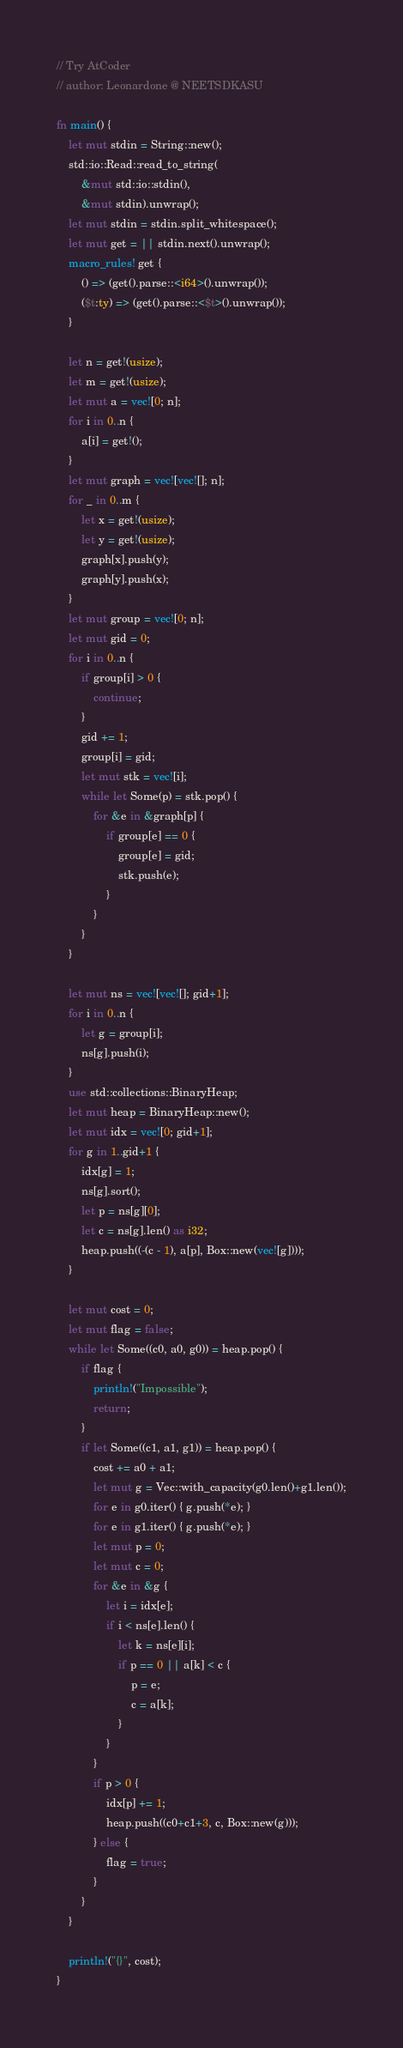<code> <loc_0><loc_0><loc_500><loc_500><_Rust_>// Try AtCoder
// author: Leonardone @ NEETSDKASU

fn main() {
    let mut stdin = String::new();
    std::io::Read::read_to_string(
    	&mut std::io::stdin(),
        &mut stdin).unwrap();
	let mut stdin = stdin.split_whitespace();
    let mut get = || stdin.next().unwrap();
    macro_rules! get {
    	() => (get().parse::<i64>().unwrap());
        ($t:ty) => (get().parse::<$t>().unwrap());
    }
    
    let n = get!(usize);
    let m = get!(usize);
    let mut a = vec![0; n];
    for i in 0..n {
    	a[i] = get!();
    }
    let mut graph = vec![vec![]; n];
    for _ in 0..m {
    	let x = get!(usize);
    	let y = get!(usize);
        graph[x].push(y);
        graph[y].push(x);
    }
    let mut group = vec![0; n];
    let mut gid = 0;
    for i in 0..n {
    	if group[i] > 0 {
        	continue;
        }
        gid += 1;
        group[i] = gid;
        let mut stk = vec![i];
        while let Some(p) = stk.pop() {
        	for &e in &graph[p] {
            	if group[e] == 0 {
                	group[e] = gid;
                    stk.push(e);
                }
            }
        }
    }
    
    let mut ns = vec![vec![]; gid+1];
    for i in 0..n {
    	let g = group[i];
        ns[g].push(i);
    }
    use std::collections::BinaryHeap;
    let mut heap = BinaryHeap::new();
    let mut idx = vec![0; gid+1];
    for g in 1..gid+1 {
    	idx[g] = 1;
    	ns[g].sort();
        let p = ns[g][0];
        let c = ns[g].len() as i32;
        heap.push((-(c - 1), a[p], Box::new(vec![g])));
    }
    
    let mut cost = 0;
    let mut flag = false;
    while let Some((c0, a0, g0)) = heap.pop() {
    	if flag {
        	println!("Impossible");
            return;
        }
    	if let Some((c1, a1, g1)) = heap.pop() {
			cost += a0 + a1;
            let mut g = Vec::with_capacity(g0.len()+g1.len());
            for e in g0.iter() { g.push(*e); }
            for e in g1.iter() { g.push(*e); }
            let mut p = 0;
            let mut c = 0;
            for &e in &g {
            	let i = idx[e];
                if i < ns[e].len() {
                	let k = ns[e][i];
                	if p == 0 || a[k] < c {
                    	p = e;
                        c = a[k];
                    }
                }
            }
            if p > 0 {
            	idx[p] += 1;
                heap.push((c0+c1+3, c, Box::new(g)));
            } else {
            	flag = true;
            }
        }
    }
    
    println!("{}", cost);
}</code> 